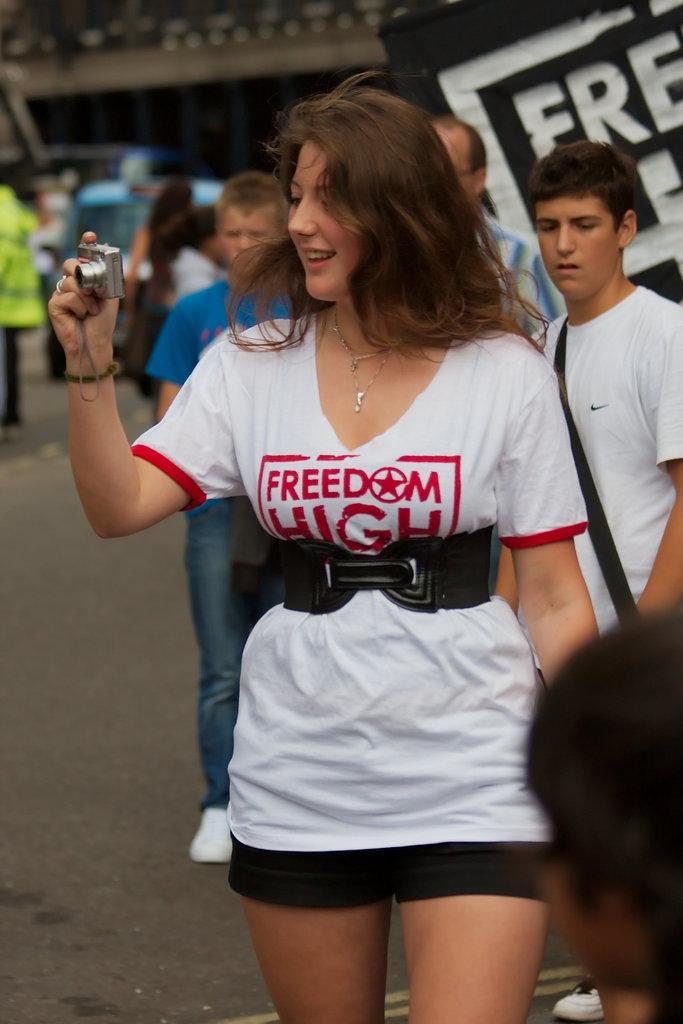<image>
Present a compact description of the photo's key features. An attractive young lady wearing a white T-shirt with the slogan Freedom High takes a photo of those around her with a camera. 